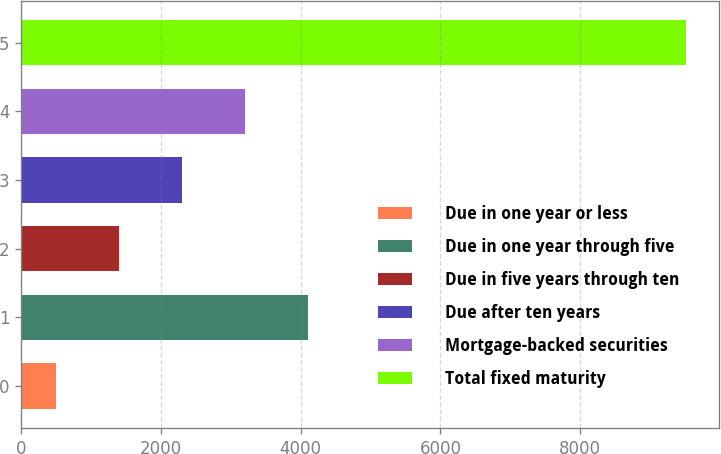<chart> <loc_0><loc_0><loc_500><loc_500><bar_chart><fcel>Due in one year or less<fcel>Due in one year through five<fcel>Due in five years through ten<fcel>Due after ten years<fcel>Mortgage-backed securities<fcel>Total fixed maturity<nl><fcel>502<fcel>4112<fcel>1409<fcel>2310<fcel>3211<fcel>9512<nl></chart> 